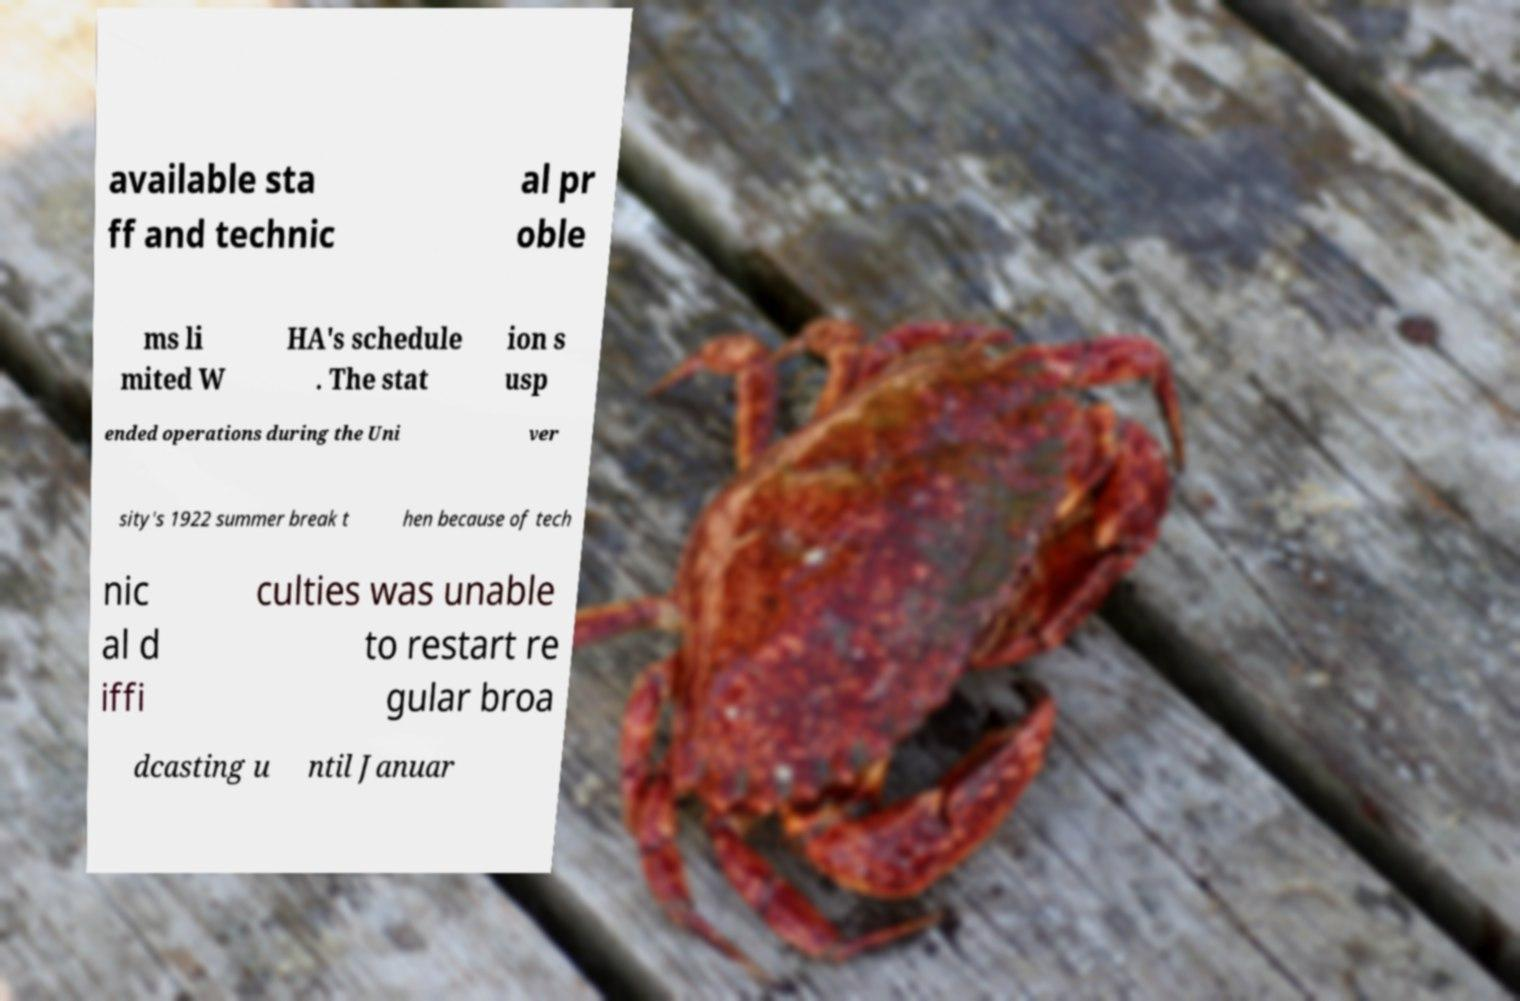Please read and relay the text visible in this image. What does it say? available sta ff and technic al pr oble ms li mited W HA's schedule . The stat ion s usp ended operations during the Uni ver sity's 1922 summer break t hen because of tech nic al d iffi culties was unable to restart re gular broa dcasting u ntil Januar 